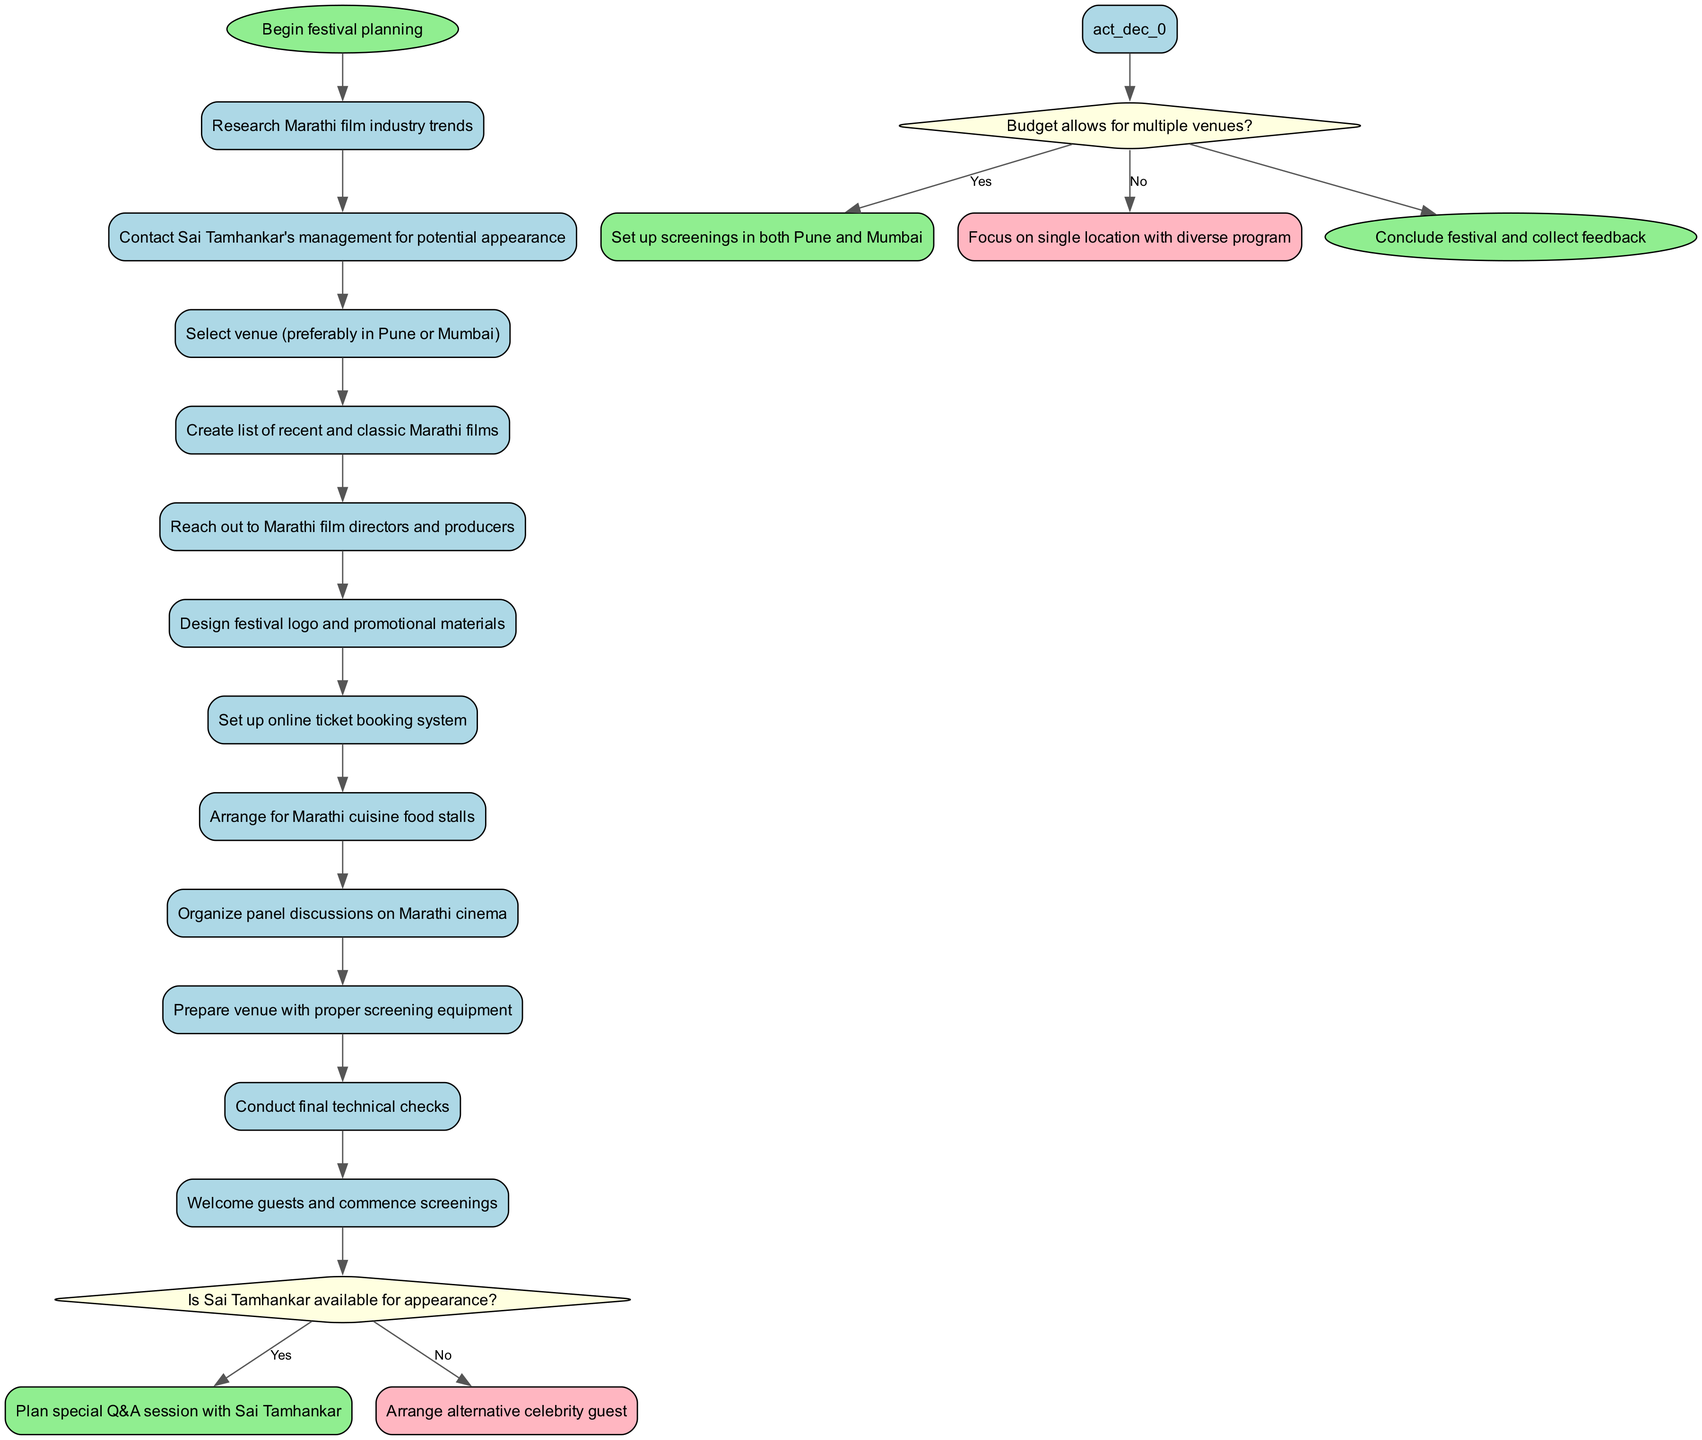What is the starting activity of the diagram? The first activity listed in the diagram is "Research Marathi film industry trends," which follows the start node.
Answer: Research Marathi film industry trends How many activities are there in total? By counting the number of activities provided in the activities list, we find 12 activities total from start to finish (including the first and last).
Answer: 12 What decision follows the activity "Contact Sai Tamhankar's management for potential appearance"? The decision node that follows this activity is "Is Sai Tamhankar available for appearance?" which assesses the availability of the celebrity guest.
Answer: Is Sai Tamhankar available for appearance? What happens if Sai Tamhankar is not available? If Sai Tamhankar is not available, the diagram indicates that the next step is to "Arrange alternative celebrity guest," providing a clear alternative for the festival planning.
Answer: Arrange alternative celebrity guest What is the last activity in the diagram before concluding the festival? The final activity listed before concluding the festival is "Welcome guests and commence screenings." This activity signifies the initiation of the event on the day itself.
Answer: Welcome guests and commence screenings If the budget allows for multiple venues, what is the next step? If the budget allows for multiple venues, the diagram suggests that the next step is to "Set up screenings in both Pune and Mumbai," thus expanding the festival's reach.
Answer: Set up screenings in both Pune and Mumbai What color represents the decision nodes in the diagram? The decision nodes in the diagram are represented in light yellow color, distinguishing them from activity and end nodes.
Answer: Light yellow What is the end goal of the festival planning process as shown in the diagram? The end goal of the festival planning process is to "Conclude festival and collect feedback," which encapsulates the final stages of the event.
Answer: Conclude festival and collect feedback 